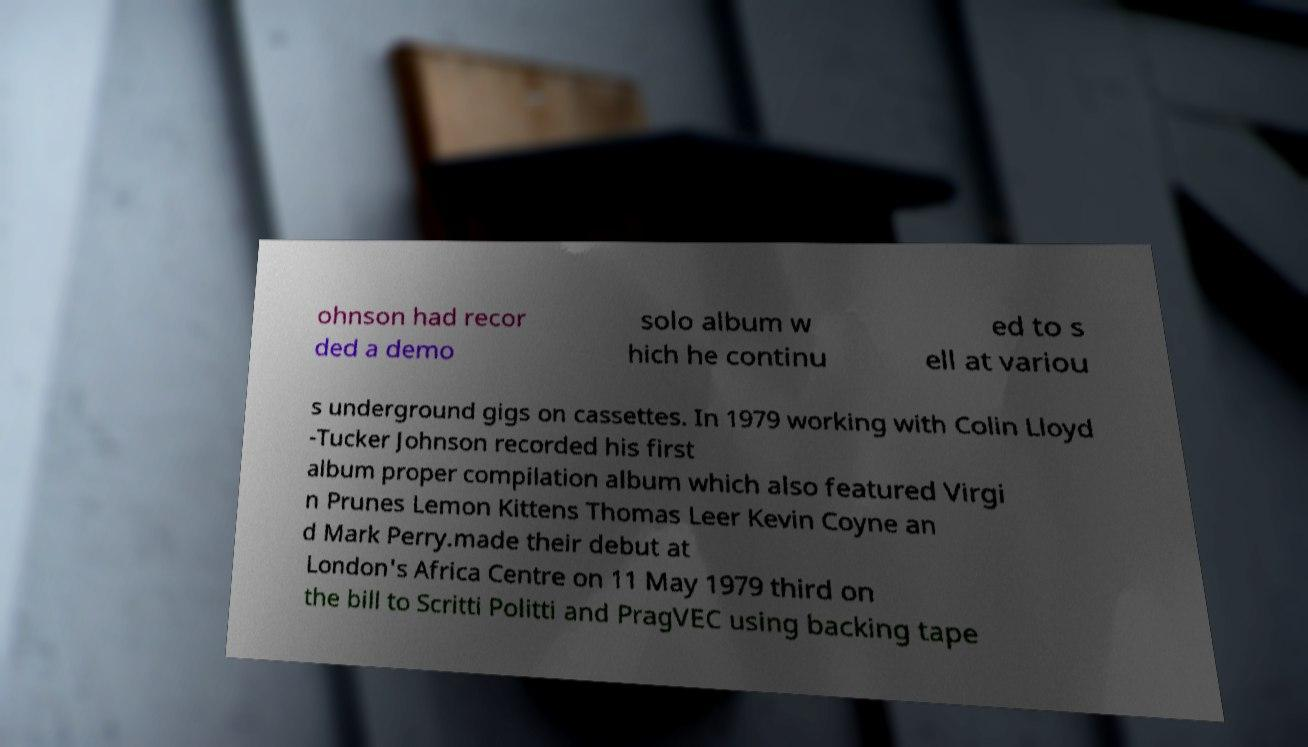Please read and relay the text visible in this image. What does it say? ohnson had recor ded a demo solo album w hich he continu ed to s ell at variou s underground gigs on cassettes. In 1979 working with Colin Lloyd -Tucker Johnson recorded his first album proper compilation album which also featured Virgi n Prunes Lemon Kittens Thomas Leer Kevin Coyne an d Mark Perry.made their debut at London's Africa Centre on 11 May 1979 third on the bill to Scritti Politti and PragVEC using backing tape 